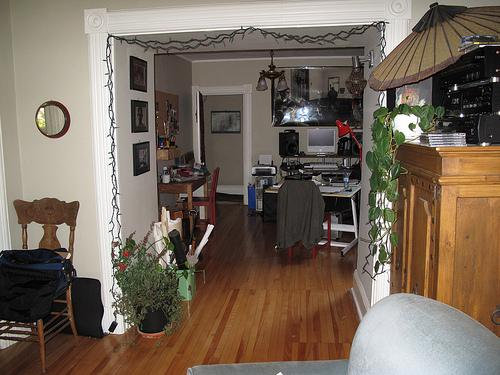Question: what is draped across the front entryway?
Choices:
A. Garland.
B. Bows.
C. Christmas lights.
D. A sign.
Answer with the letter. Answer: C Question: what can be seen at the top right?
Choices:
A. A street light.
B. A plane.
C. An umbrella.
D. A bird.
Answer with the letter. Answer: C Question: what kind of floor is this?
Choices:
A. Tile.
B. Hardwood.
C. Carpet.
D. Vinyl.
Answer with the letter. Answer: B Question: who is in the room?
Choices:
A. One person.
B. Grandmother.
C. Nobody.
D. Lady.
Answer with the letter. Answer: C Question: how many plants are visible?
Choices:
A. None.
B. Two.
C. One.
D. Three.
Answer with the letter. Answer: B 